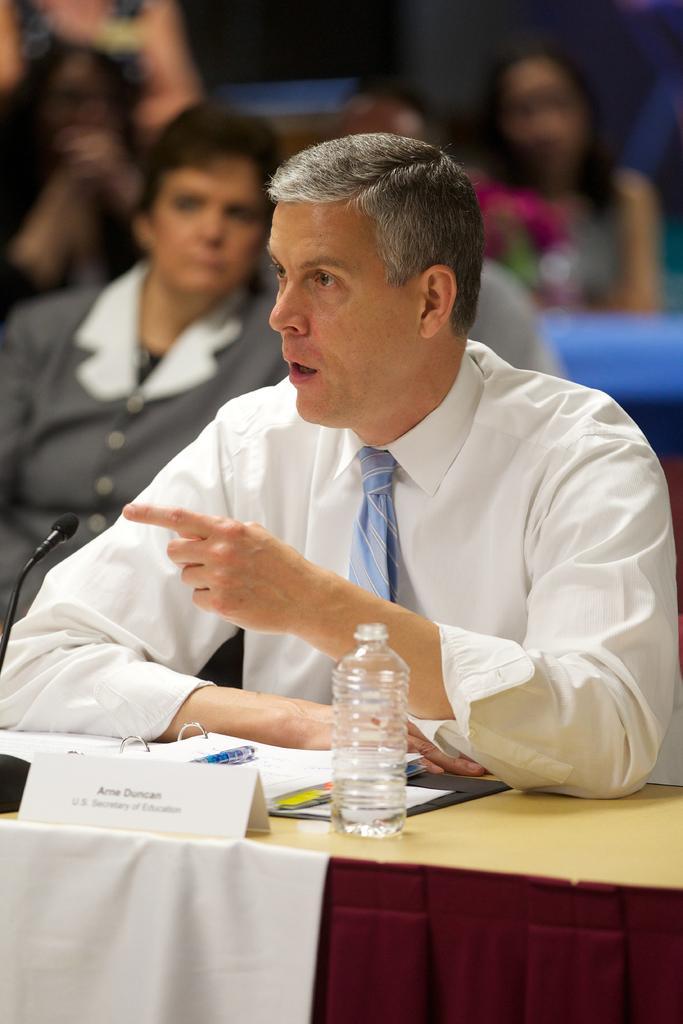Could you give a brief overview of what you see in this image? In this image there is a table, on that table there are papers, board and a bottle and a mike, behind the table there is a man sitting on a chair, in the background there are people sitting on chairs and it is blurred. 